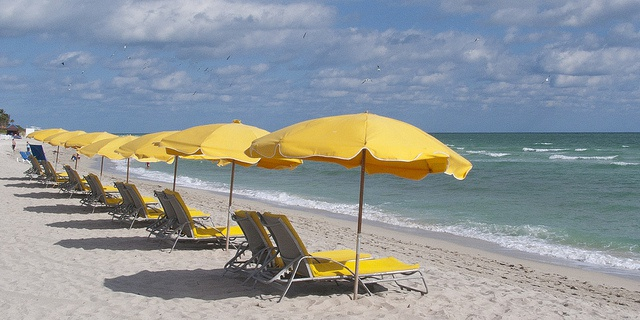Describe the objects in this image and their specific colors. I can see umbrella in darkgray, khaki, olive, and gold tones, chair in darkgray, gray, gold, and olive tones, umbrella in darkgray, khaki, tan, and olive tones, chair in darkgray, gray, black, and olive tones, and chair in darkgray, gray, olive, black, and gold tones in this image. 